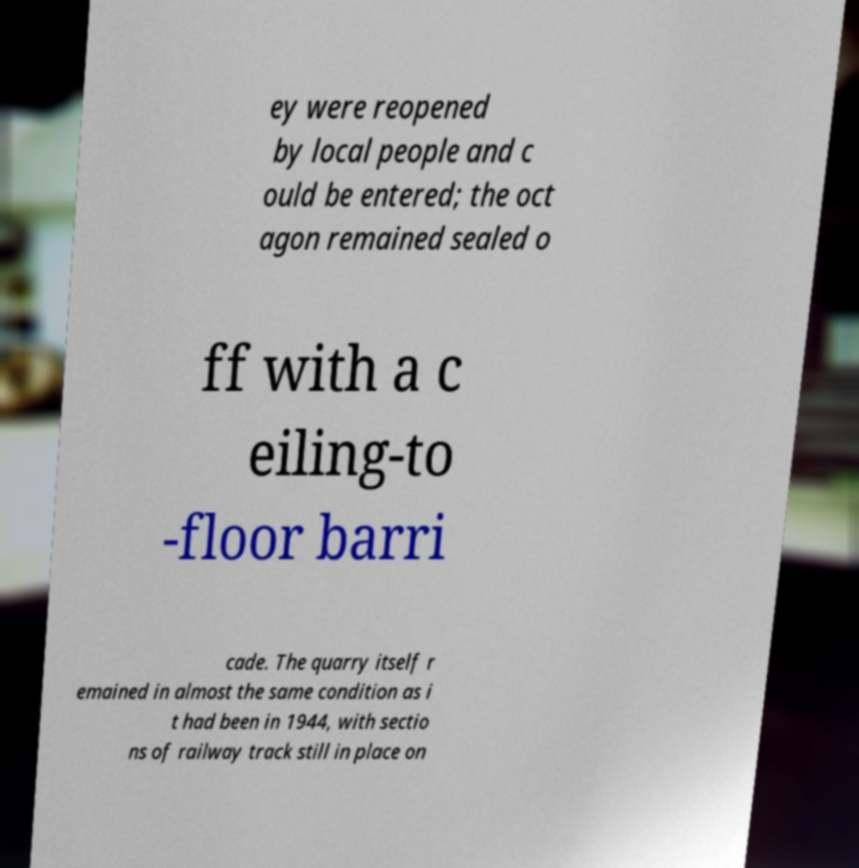Can you accurately transcribe the text from the provided image for me? ey were reopened by local people and c ould be entered; the oct agon remained sealed o ff with a c eiling-to -floor barri cade. The quarry itself r emained in almost the same condition as i t had been in 1944, with sectio ns of railway track still in place on 